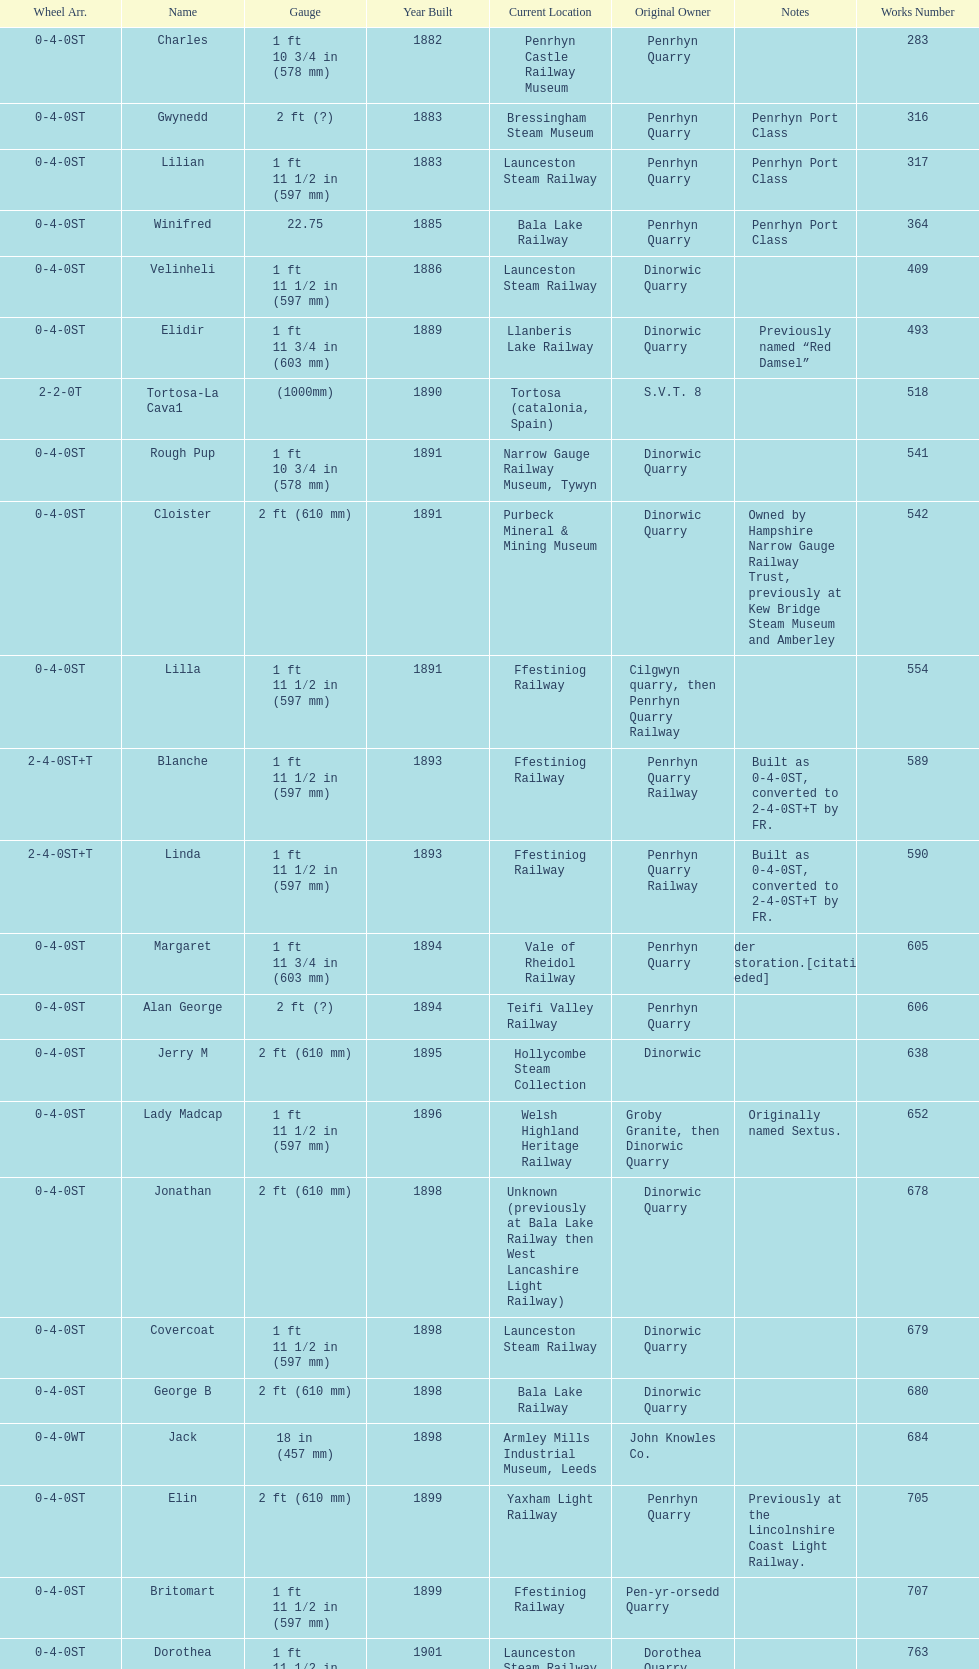After 1940, how many steam locomotives were built? 2. 